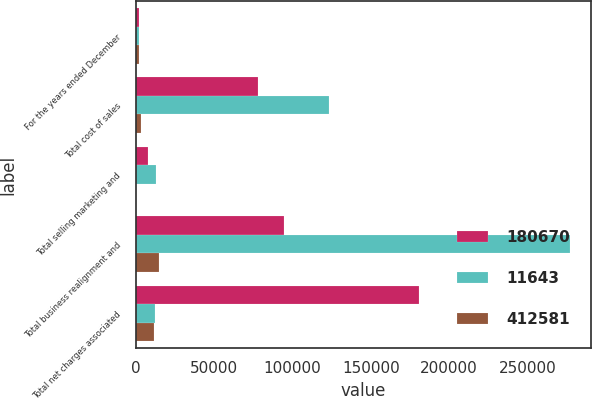Convert chart. <chart><loc_0><loc_0><loc_500><loc_500><stacked_bar_chart><ecel><fcel>For the years ended December<fcel>Total cost of sales<fcel>Total selling marketing and<fcel>Total business realignment and<fcel>Total net charges associated<nl><fcel>180670<fcel>2008<fcel>77767<fcel>8102<fcel>94801<fcel>180670<nl><fcel>11643<fcel>2007<fcel>123090<fcel>12623<fcel>276868<fcel>12133<nl><fcel>412581<fcel>2006<fcel>3199<fcel>266<fcel>14576<fcel>11643<nl></chart> 